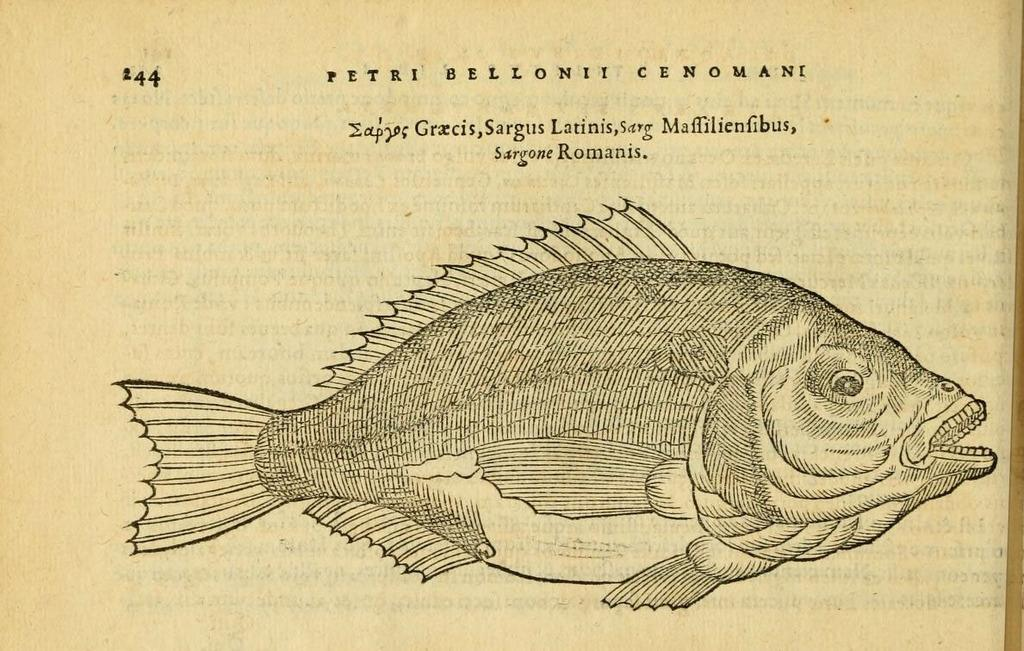What is depicted on the paper in the image? There is a sketch of a fish on the paper. What else can be seen on the paper besides the sketch? There is text and a page number on the paper. What type of cabbage is the son holding in the image? There is no son or cabbage present in the image; it only features a paper with a sketch of a fish, text, and a page number. 